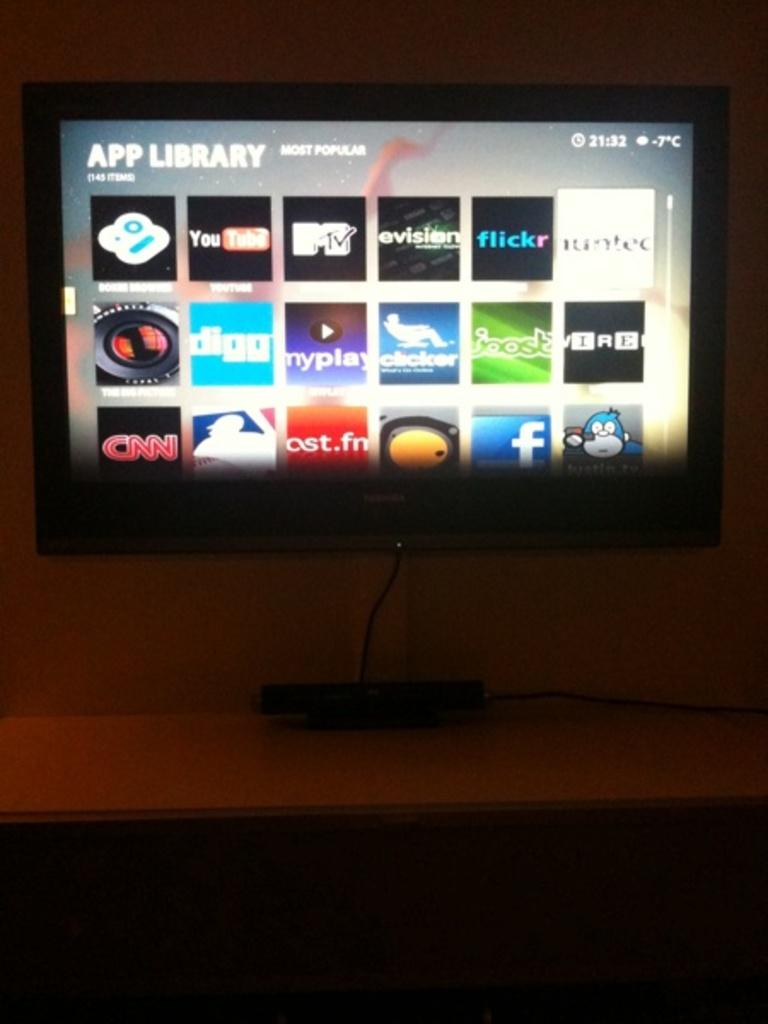Provide a one-sentence caption for the provided image. A television mounted to the wall has several different apps showing under the heading app library. 